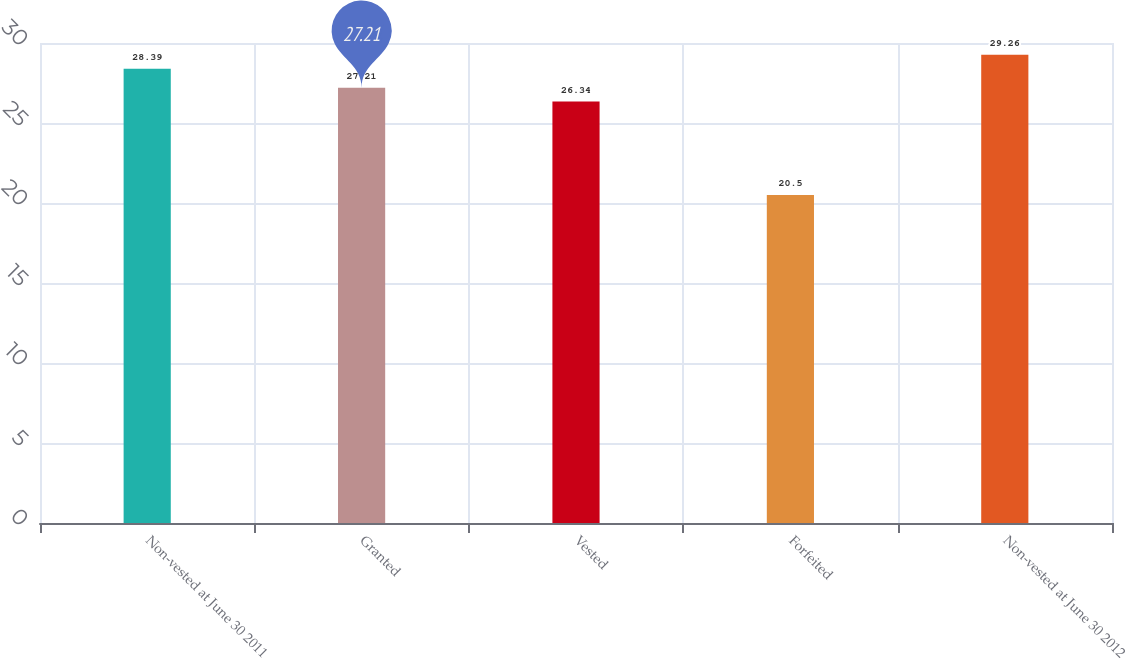Convert chart. <chart><loc_0><loc_0><loc_500><loc_500><bar_chart><fcel>Non-vested at June 30 2011<fcel>Granted<fcel>Vested<fcel>Forfeited<fcel>Non-vested at June 30 2012<nl><fcel>28.39<fcel>27.21<fcel>26.34<fcel>20.5<fcel>29.26<nl></chart> 